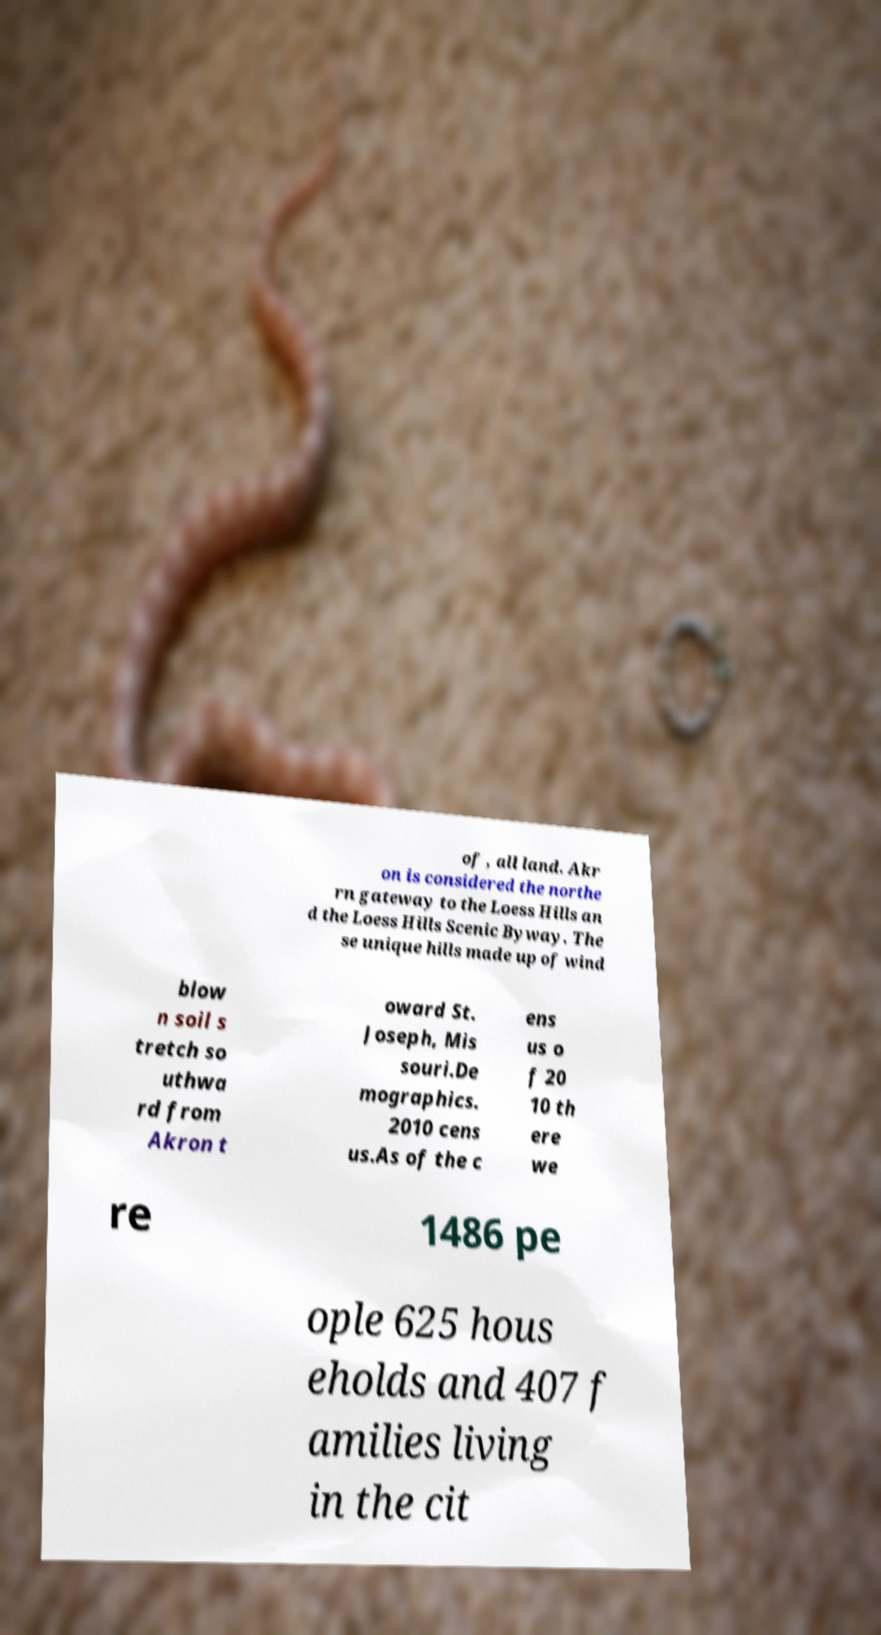There's text embedded in this image that I need extracted. Can you transcribe it verbatim? of , all land. Akr on is considered the northe rn gateway to the Loess Hills an d the Loess Hills Scenic Byway. The se unique hills made up of wind blow n soil s tretch so uthwa rd from Akron t oward St. Joseph, Mis souri.De mographics. 2010 cens us.As of the c ens us o f 20 10 th ere we re 1486 pe ople 625 hous eholds and 407 f amilies living in the cit 